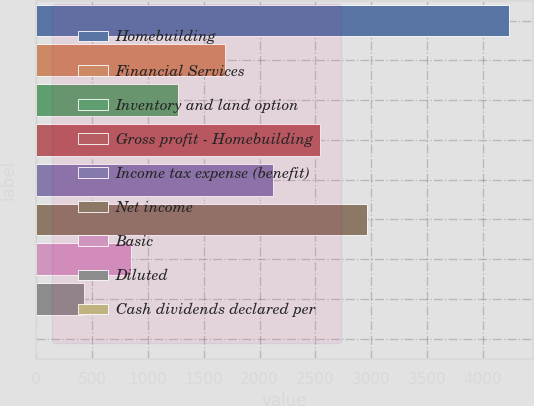Convert chart. <chart><loc_0><loc_0><loc_500><loc_500><bar_chart><fcel>Homebuilding<fcel>Financial Services<fcel>Inventory and land option<fcel>Gross profit - Homebuilding<fcel>Income tax expense (benefit)<fcel>Net income<fcel>Basic<fcel>Diluted<fcel>Cash dividends declared per<nl><fcel>4236.2<fcel>1694.58<fcel>1270.97<fcel>2541.78<fcel>2118.18<fcel>2965.39<fcel>847.36<fcel>423.75<fcel>0.15<nl></chart> 